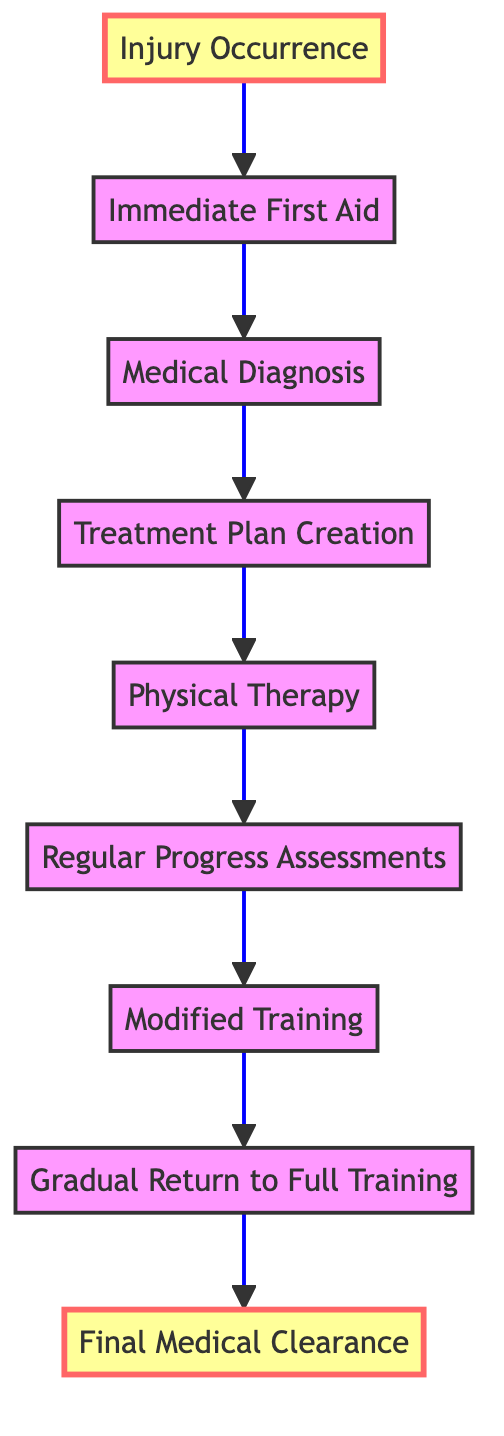What is the first step in the injury recovery process? The first step is labeled "Injury Occurrence," indicating that the gymnast sustains an injury during training or competition.
Answer: Injury Occurrence How many steps are there in the injury recovery process? Counting each of the steps from "Injury Occurrence" to "Final Medical Clearance," there are a total of 9 steps in the process.
Answer: 9 What follows "Immediate First Aid" in the process? The step that comes after "Immediate First Aid" is "Medical Diagnosis," which involves visiting a sports doctor for a thorough diagnosis.
Answer: Medical Diagnosis Which step involves working with a physiotherapist? The step that involves engagement with a physiotherapist is "Physical Therapy," where the gymnast works to regain strength and mobility.
Answer: Physical Therapy What is the last step in the recovery process? The last step is "Final Medical Clearance," where the gymnast obtains confirmation of full recovery from the doctor.
Answer: Final Medical Clearance What is required before proceeding to modified training? Prior to modified training, a "Treatment Plan Creation" is necessary, where a doctor drafts a plan involving rest, physiotherapy, or surgery.
Answer: Treatment Plan Creation What type of assessments are done during recovery? The assessments conducted during recovery are termed "Regular Progress Assessments," which are routine check-ups by the doctor to monitor recovery progress.
Answer: Regular Progress Assessments What does "Gradual Return to Full Training" entail? This step involves progressively increasing training intensity under careful supervision until the gymnast is fully rehabilitated.
Answer: Progressively increase training intensity What is the purpose of the "Regular Progress Assessments"? The purpose is to monitor recovery progress through routine check-ups and assessments by the doctor.
Answer: Monitor recovery progress 